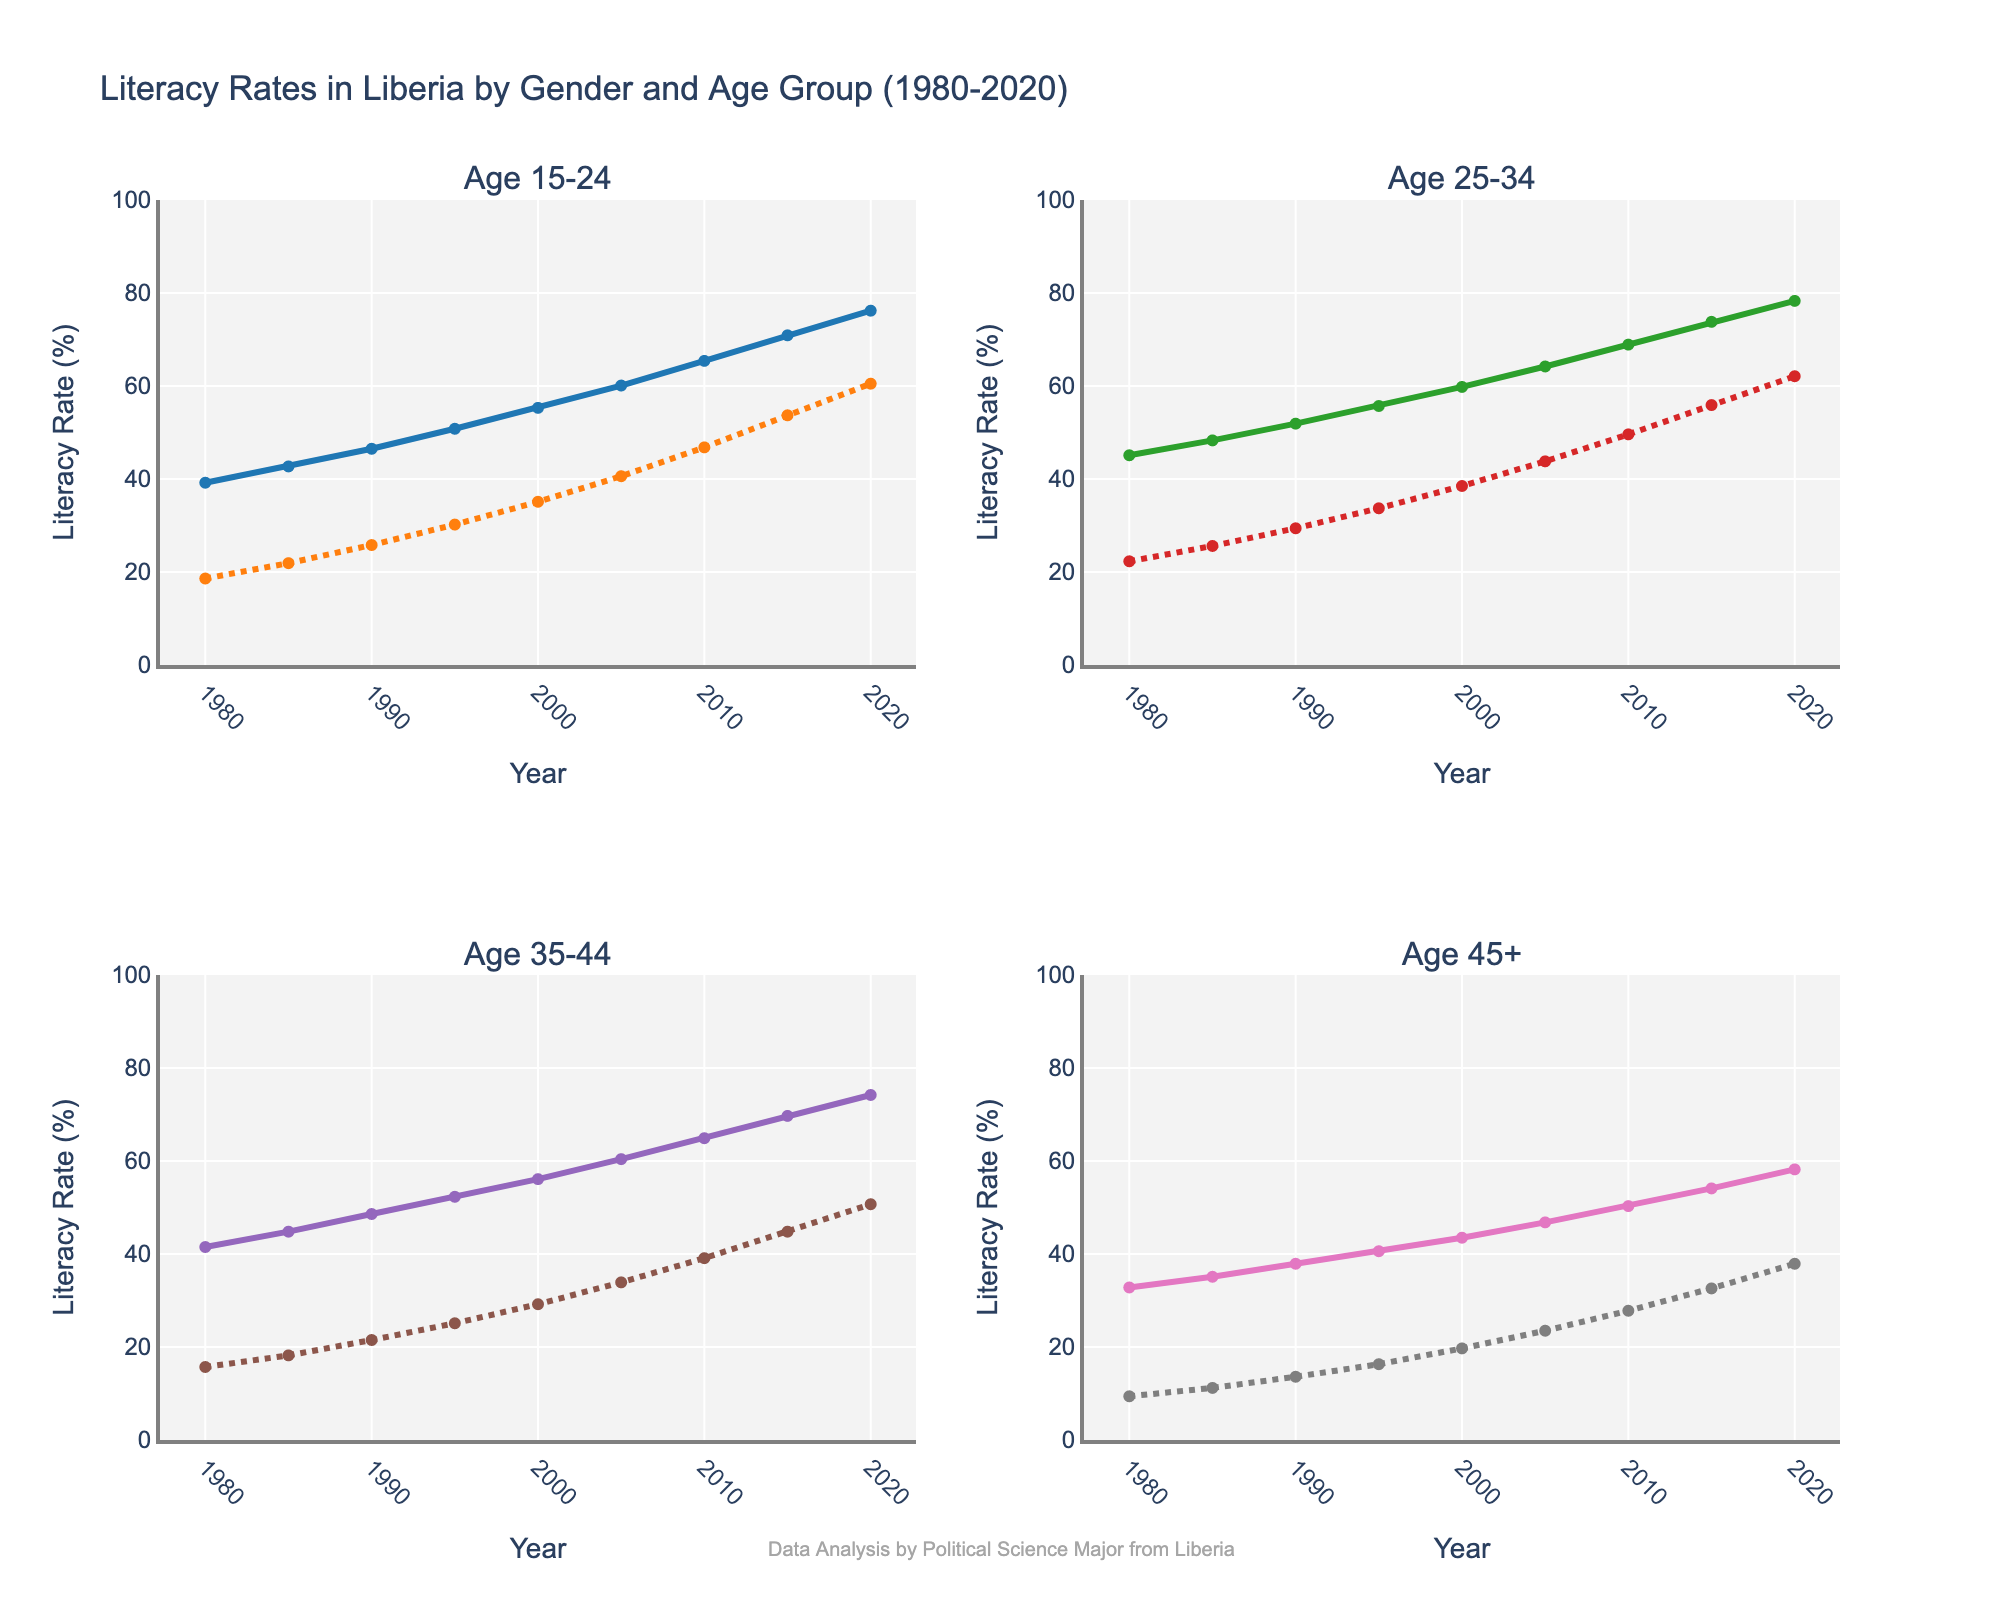What was the literacy rate for males aged 15-24 in 1990? The figure shows a plot for literacy rates by year. Referring to the section for males aged 15-24, locate the value for 1990 on the y-axis.
Answer: 46.5 How much did the literacy rate for females aged 35-44 increase from 1980 to 2020? Find the literacy rate for females aged 35-44 in 2020 and 1980 from the chart. Subtract the 1980 value from the 2020 value.
Answer: 50.7 - 15.7 = 35.0 Which gender had a higher literacy rate in the age group 25-34 in 2005? Compare the literacy rates for males and females aged 25-34 in the year 2005 by looking at the respective lines on the chart.
Answer: Male By how many percentage points did the literacy rate for males aged 45+ change from 2000 to 2015? Find the literacy rates for males aged 45+ for the years 2000 and 2015. Subtract the 2000 literacy rate from the 2015 literacy rate.
Answer: 54.1 - 43.5 = 10.6 What is the general trend in literacy rates for females aged 15-24 from 1980 to 2020? Observe the trajectory of the line representing females aged 15-24 over time. Note whether it is rising, falling, or stable.
Answer: Increasing Which age group showed the most significant improvement in literacy rates for males from 1980 to 2020? Compare the increase in literacy rates for all male age groups from 1980 to 2020 by examining the lines on the chart for each respective age group.
Answer: Age 15-24 Is the increase in literacy rates for males aged 35-44 between 1990 and 2000 greater than the increase between 2000 and 2010? Calculate the difference in literacy rates between 1990 and 2000 and between 2000 and 2010 for males aged 35-44. Compare the two increments to determine which is greater.
Answer: No What was the literacy rate in 1985 for females aged 45+ and how does it compare to 2015 for the same group? Find the literacy rates for females aged 45+ in 1985 and 2015, and compare them by examining the two points and their respective values.
Answer: 11.2 in 1985, 32.6 in 2015; higher in 2015 Between 1995 and 2005, did females aged 25-34 experience a greater increase in literacy rates compared to males of the same age group? Calculate the increase in literacy rates for both males and females aged 25-34 between 1995 and 2005. Compare the increments to see which gender experienced a greater increase.
Answer: No 